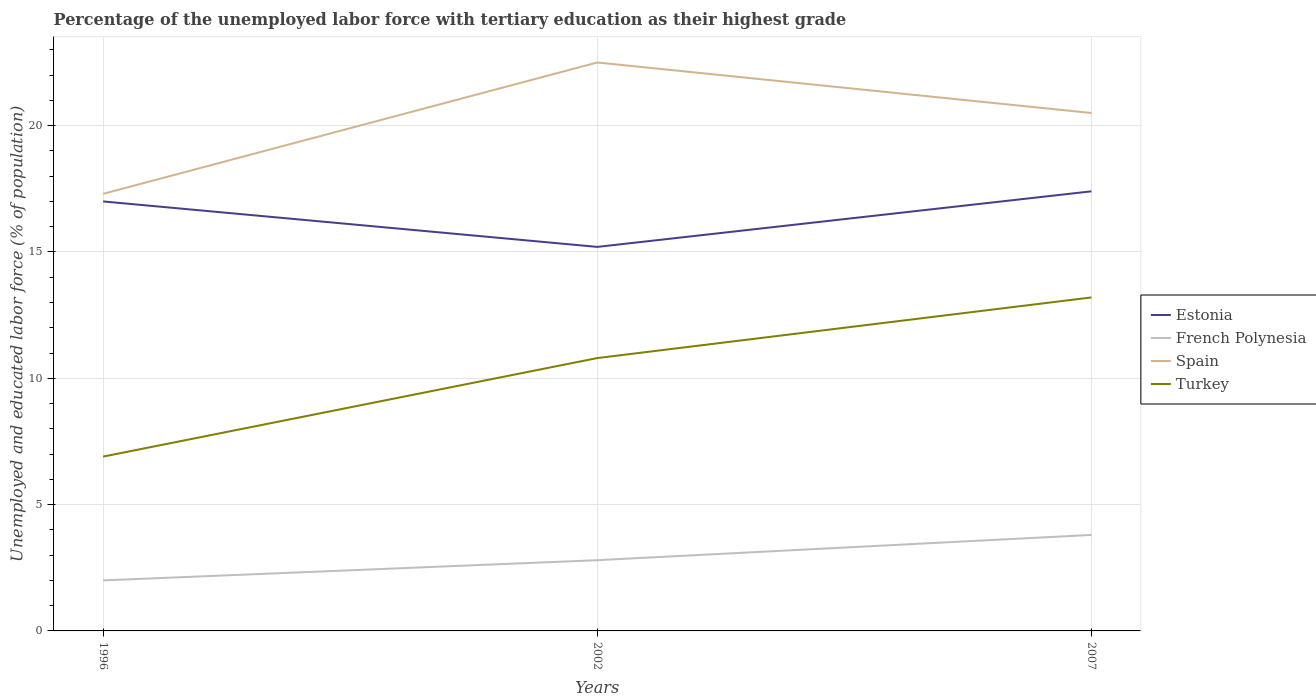Does the line corresponding to French Polynesia intersect with the line corresponding to Spain?
Your response must be concise. No. Across all years, what is the maximum percentage of the unemployed labor force with tertiary education in Turkey?
Keep it short and to the point. 6.9. In which year was the percentage of the unemployed labor force with tertiary education in Estonia maximum?
Provide a succinct answer. 2002. What is the difference between the highest and the second highest percentage of the unemployed labor force with tertiary education in Spain?
Provide a short and direct response. 5.2. What is the difference between the highest and the lowest percentage of the unemployed labor force with tertiary education in Estonia?
Your response must be concise. 2. How many years are there in the graph?
Offer a very short reply. 3. What is the difference between two consecutive major ticks on the Y-axis?
Your answer should be very brief. 5. Does the graph contain any zero values?
Provide a short and direct response. No. What is the title of the graph?
Provide a short and direct response. Percentage of the unemployed labor force with tertiary education as their highest grade. Does "Libya" appear as one of the legend labels in the graph?
Give a very brief answer. No. What is the label or title of the X-axis?
Your answer should be compact. Years. What is the label or title of the Y-axis?
Provide a short and direct response. Unemployed and educated labor force (% of population). What is the Unemployed and educated labor force (% of population) in Estonia in 1996?
Make the answer very short. 17. What is the Unemployed and educated labor force (% of population) in French Polynesia in 1996?
Provide a succinct answer. 2. What is the Unemployed and educated labor force (% of population) in Spain in 1996?
Provide a succinct answer. 17.3. What is the Unemployed and educated labor force (% of population) in Turkey in 1996?
Give a very brief answer. 6.9. What is the Unemployed and educated labor force (% of population) in Estonia in 2002?
Keep it short and to the point. 15.2. What is the Unemployed and educated labor force (% of population) in French Polynesia in 2002?
Your response must be concise. 2.8. What is the Unemployed and educated labor force (% of population) of Spain in 2002?
Provide a short and direct response. 22.5. What is the Unemployed and educated labor force (% of population) in Turkey in 2002?
Offer a very short reply. 10.8. What is the Unemployed and educated labor force (% of population) in Estonia in 2007?
Your response must be concise. 17.4. What is the Unemployed and educated labor force (% of population) of French Polynesia in 2007?
Provide a succinct answer. 3.8. What is the Unemployed and educated labor force (% of population) in Turkey in 2007?
Provide a short and direct response. 13.2. Across all years, what is the maximum Unemployed and educated labor force (% of population) in Estonia?
Ensure brevity in your answer.  17.4. Across all years, what is the maximum Unemployed and educated labor force (% of population) in French Polynesia?
Offer a terse response. 3.8. Across all years, what is the maximum Unemployed and educated labor force (% of population) in Spain?
Make the answer very short. 22.5. Across all years, what is the maximum Unemployed and educated labor force (% of population) of Turkey?
Offer a terse response. 13.2. Across all years, what is the minimum Unemployed and educated labor force (% of population) of Estonia?
Make the answer very short. 15.2. Across all years, what is the minimum Unemployed and educated labor force (% of population) in Spain?
Make the answer very short. 17.3. Across all years, what is the minimum Unemployed and educated labor force (% of population) of Turkey?
Keep it short and to the point. 6.9. What is the total Unemployed and educated labor force (% of population) in Estonia in the graph?
Keep it short and to the point. 49.6. What is the total Unemployed and educated labor force (% of population) of French Polynesia in the graph?
Make the answer very short. 8.6. What is the total Unemployed and educated labor force (% of population) in Spain in the graph?
Give a very brief answer. 60.3. What is the total Unemployed and educated labor force (% of population) in Turkey in the graph?
Offer a terse response. 30.9. What is the difference between the Unemployed and educated labor force (% of population) in French Polynesia in 1996 and that in 2002?
Provide a succinct answer. -0.8. What is the difference between the Unemployed and educated labor force (% of population) in Spain in 1996 and that in 2002?
Keep it short and to the point. -5.2. What is the difference between the Unemployed and educated labor force (% of population) in French Polynesia in 1996 and that in 2007?
Ensure brevity in your answer.  -1.8. What is the difference between the Unemployed and educated labor force (% of population) in Estonia in 2002 and that in 2007?
Your answer should be compact. -2.2. What is the difference between the Unemployed and educated labor force (% of population) of French Polynesia in 2002 and that in 2007?
Ensure brevity in your answer.  -1. What is the difference between the Unemployed and educated labor force (% of population) in Spain in 2002 and that in 2007?
Offer a terse response. 2. What is the difference between the Unemployed and educated labor force (% of population) of Estonia in 1996 and the Unemployed and educated labor force (% of population) of French Polynesia in 2002?
Your answer should be very brief. 14.2. What is the difference between the Unemployed and educated labor force (% of population) of Estonia in 1996 and the Unemployed and educated labor force (% of population) of Turkey in 2002?
Offer a very short reply. 6.2. What is the difference between the Unemployed and educated labor force (% of population) in French Polynesia in 1996 and the Unemployed and educated labor force (% of population) in Spain in 2002?
Make the answer very short. -20.5. What is the difference between the Unemployed and educated labor force (% of population) in French Polynesia in 1996 and the Unemployed and educated labor force (% of population) in Turkey in 2002?
Make the answer very short. -8.8. What is the difference between the Unemployed and educated labor force (% of population) of Spain in 1996 and the Unemployed and educated labor force (% of population) of Turkey in 2002?
Your answer should be very brief. 6.5. What is the difference between the Unemployed and educated labor force (% of population) of Estonia in 1996 and the Unemployed and educated labor force (% of population) of Spain in 2007?
Make the answer very short. -3.5. What is the difference between the Unemployed and educated labor force (% of population) of Estonia in 1996 and the Unemployed and educated labor force (% of population) of Turkey in 2007?
Your answer should be compact. 3.8. What is the difference between the Unemployed and educated labor force (% of population) in French Polynesia in 1996 and the Unemployed and educated labor force (% of population) in Spain in 2007?
Keep it short and to the point. -18.5. What is the difference between the Unemployed and educated labor force (% of population) in Estonia in 2002 and the Unemployed and educated labor force (% of population) in French Polynesia in 2007?
Keep it short and to the point. 11.4. What is the difference between the Unemployed and educated labor force (% of population) in Estonia in 2002 and the Unemployed and educated labor force (% of population) in Turkey in 2007?
Provide a succinct answer. 2. What is the difference between the Unemployed and educated labor force (% of population) of French Polynesia in 2002 and the Unemployed and educated labor force (% of population) of Spain in 2007?
Provide a succinct answer. -17.7. What is the difference between the Unemployed and educated labor force (% of population) of Spain in 2002 and the Unemployed and educated labor force (% of population) of Turkey in 2007?
Make the answer very short. 9.3. What is the average Unemployed and educated labor force (% of population) in Estonia per year?
Provide a short and direct response. 16.53. What is the average Unemployed and educated labor force (% of population) of French Polynesia per year?
Keep it short and to the point. 2.87. What is the average Unemployed and educated labor force (% of population) of Spain per year?
Your answer should be compact. 20.1. In the year 1996, what is the difference between the Unemployed and educated labor force (% of population) in Estonia and Unemployed and educated labor force (% of population) in French Polynesia?
Offer a terse response. 15. In the year 1996, what is the difference between the Unemployed and educated labor force (% of population) of Estonia and Unemployed and educated labor force (% of population) of Turkey?
Keep it short and to the point. 10.1. In the year 1996, what is the difference between the Unemployed and educated labor force (% of population) in French Polynesia and Unemployed and educated labor force (% of population) in Spain?
Your response must be concise. -15.3. In the year 1996, what is the difference between the Unemployed and educated labor force (% of population) in French Polynesia and Unemployed and educated labor force (% of population) in Turkey?
Your response must be concise. -4.9. In the year 1996, what is the difference between the Unemployed and educated labor force (% of population) in Spain and Unemployed and educated labor force (% of population) in Turkey?
Your response must be concise. 10.4. In the year 2002, what is the difference between the Unemployed and educated labor force (% of population) in Estonia and Unemployed and educated labor force (% of population) in Spain?
Ensure brevity in your answer.  -7.3. In the year 2002, what is the difference between the Unemployed and educated labor force (% of population) of French Polynesia and Unemployed and educated labor force (% of population) of Spain?
Provide a succinct answer. -19.7. In the year 2002, what is the difference between the Unemployed and educated labor force (% of population) in French Polynesia and Unemployed and educated labor force (% of population) in Turkey?
Ensure brevity in your answer.  -8. In the year 2007, what is the difference between the Unemployed and educated labor force (% of population) in Estonia and Unemployed and educated labor force (% of population) in Spain?
Provide a succinct answer. -3.1. In the year 2007, what is the difference between the Unemployed and educated labor force (% of population) in Estonia and Unemployed and educated labor force (% of population) in Turkey?
Your answer should be compact. 4.2. In the year 2007, what is the difference between the Unemployed and educated labor force (% of population) in French Polynesia and Unemployed and educated labor force (% of population) in Spain?
Your answer should be compact. -16.7. In the year 2007, what is the difference between the Unemployed and educated labor force (% of population) in French Polynesia and Unemployed and educated labor force (% of population) in Turkey?
Keep it short and to the point. -9.4. In the year 2007, what is the difference between the Unemployed and educated labor force (% of population) of Spain and Unemployed and educated labor force (% of population) of Turkey?
Your response must be concise. 7.3. What is the ratio of the Unemployed and educated labor force (% of population) in Estonia in 1996 to that in 2002?
Ensure brevity in your answer.  1.12. What is the ratio of the Unemployed and educated labor force (% of population) of Spain in 1996 to that in 2002?
Offer a very short reply. 0.77. What is the ratio of the Unemployed and educated labor force (% of population) of Turkey in 1996 to that in 2002?
Provide a short and direct response. 0.64. What is the ratio of the Unemployed and educated labor force (% of population) of Estonia in 1996 to that in 2007?
Make the answer very short. 0.98. What is the ratio of the Unemployed and educated labor force (% of population) of French Polynesia in 1996 to that in 2007?
Provide a succinct answer. 0.53. What is the ratio of the Unemployed and educated labor force (% of population) in Spain in 1996 to that in 2007?
Your answer should be compact. 0.84. What is the ratio of the Unemployed and educated labor force (% of population) of Turkey in 1996 to that in 2007?
Offer a very short reply. 0.52. What is the ratio of the Unemployed and educated labor force (% of population) of Estonia in 2002 to that in 2007?
Provide a short and direct response. 0.87. What is the ratio of the Unemployed and educated labor force (% of population) of French Polynesia in 2002 to that in 2007?
Your answer should be compact. 0.74. What is the ratio of the Unemployed and educated labor force (% of population) of Spain in 2002 to that in 2007?
Your answer should be very brief. 1.1. What is the ratio of the Unemployed and educated labor force (% of population) of Turkey in 2002 to that in 2007?
Provide a succinct answer. 0.82. What is the difference between the highest and the second highest Unemployed and educated labor force (% of population) in French Polynesia?
Provide a short and direct response. 1. What is the difference between the highest and the second highest Unemployed and educated labor force (% of population) of Spain?
Offer a terse response. 2. What is the difference between the highest and the second highest Unemployed and educated labor force (% of population) in Turkey?
Your response must be concise. 2.4. What is the difference between the highest and the lowest Unemployed and educated labor force (% of population) in Estonia?
Make the answer very short. 2.2. 